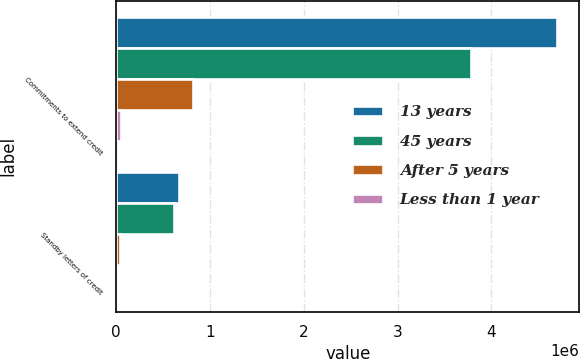Convert chart. <chart><loc_0><loc_0><loc_500><loc_500><stacked_bar_chart><ecel><fcel>Commitments to extend credit<fcel>Standby letters of credit<nl><fcel>13 years<fcel>4.70267e+06<fcel>666846<nl><fcel>45 years<fcel>3.78401e+06<fcel>622396<nl><fcel>After 5 years<fcel>823843<fcel>43983<nl><fcel>Less than 1 year<fcel>53886<fcel>430<nl></chart> 